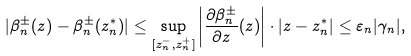<formula> <loc_0><loc_0><loc_500><loc_500>| \beta _ { n } ^ { \pm } ( z ) - \beta _ { n } ^ { \pm } ( z _ { n } ^ { * } ) | \leq \sup _ { [ z _ { n } ^ { - } , z _ { n } ^ { + } ] } \left | \frac { \partial \beta _ { n } ^ { \pm } } { \partial z } ( z ) \right | \cdot | z - z _ { n } ^ { * } | \leq \varepsilon _ { n } | \gamma _ { n } | ,</formula> 